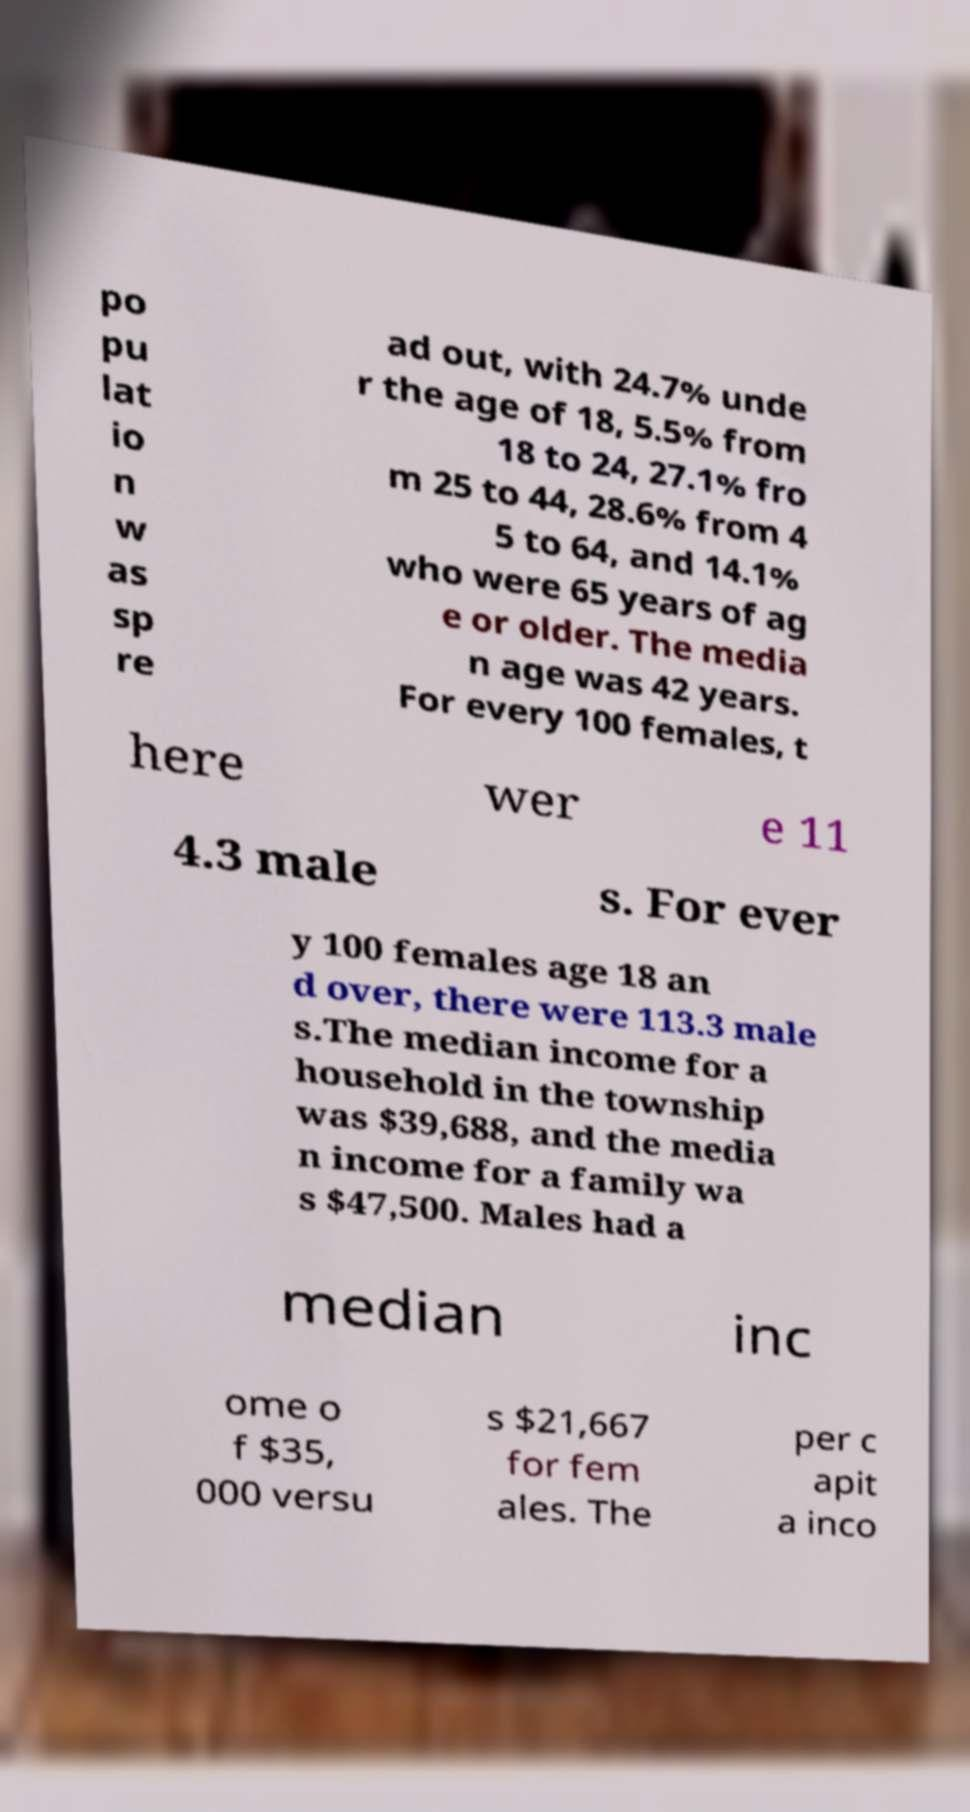Could you assist in decoding the text presented in this image and type it out clearly? po pu lat io n w as sp re ad out, with 24.7% unde r the age of 18, 5.5% from 18 to 24, 27.1% fro m 25 to 44, 28.6% from 4 5 to 64, and 14.1% who were 65 years of ag e or older. The media n age was 42 years. For every 100 females, t here wer e 11 4.3 male s. For ever y 100 females age 18 an d over, there were 113.3 male s.The median income for a household in the township was $39,688, and the media n income for a family wa s $47,500. Males had a median inc ome o f $35, 000 versu s $21,667 for fem ales. The per c apit a inco 